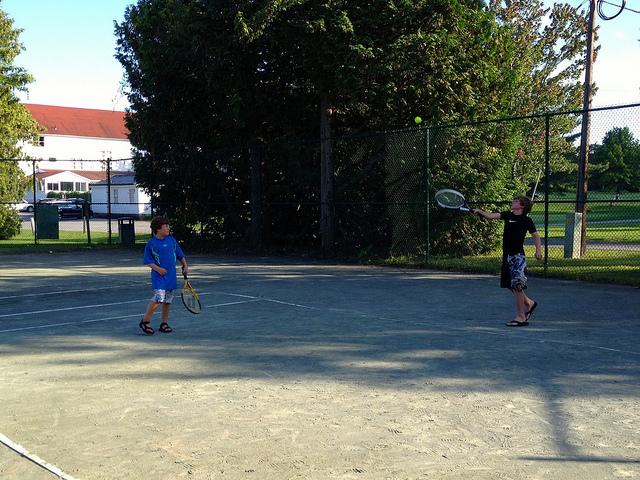What game are they playing?
Concise answer only. Tennis. Are the kids boys or girls?
Quick response, please. Boys. How many kids are wearing sandals?
Be succinct. 2. What game are these children playing?
Be succinct. Tennis. Are they playing doubles or singles?
Give a very brief answer. Doubles. What color is the building?
Be succinct. White. 